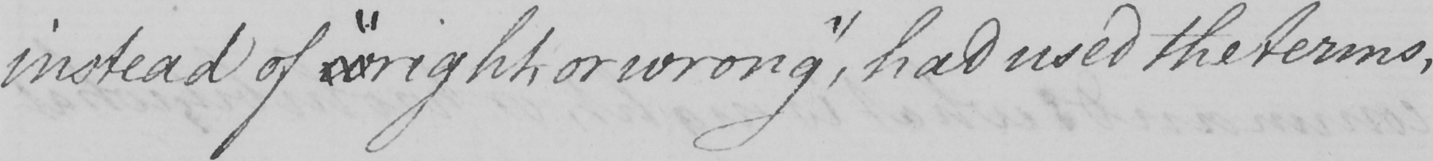What text is written in this handwritten line? instead of  " wright , or wrong "  , had used the terms , 